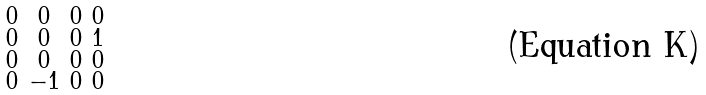<formula> <loc_0><loc_0><loc_500><loc_500>\begin{smallmatrix} 0 & 0 & 0 & 0 \\ 0 & 0 & 0 & 1 \\ 0 & 0 & 0 & 0 \\ 0 & - 1 & 0 & 0 \\ \end{smallmatrix}</formula> 